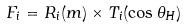Convert formula to latex. <formula><loc_0><loc_0><loc_500><loc_500>F _ { i } = R _ { i } ( m ) \times T _ { i } ( \cos \theta _ { H } )</formula> 